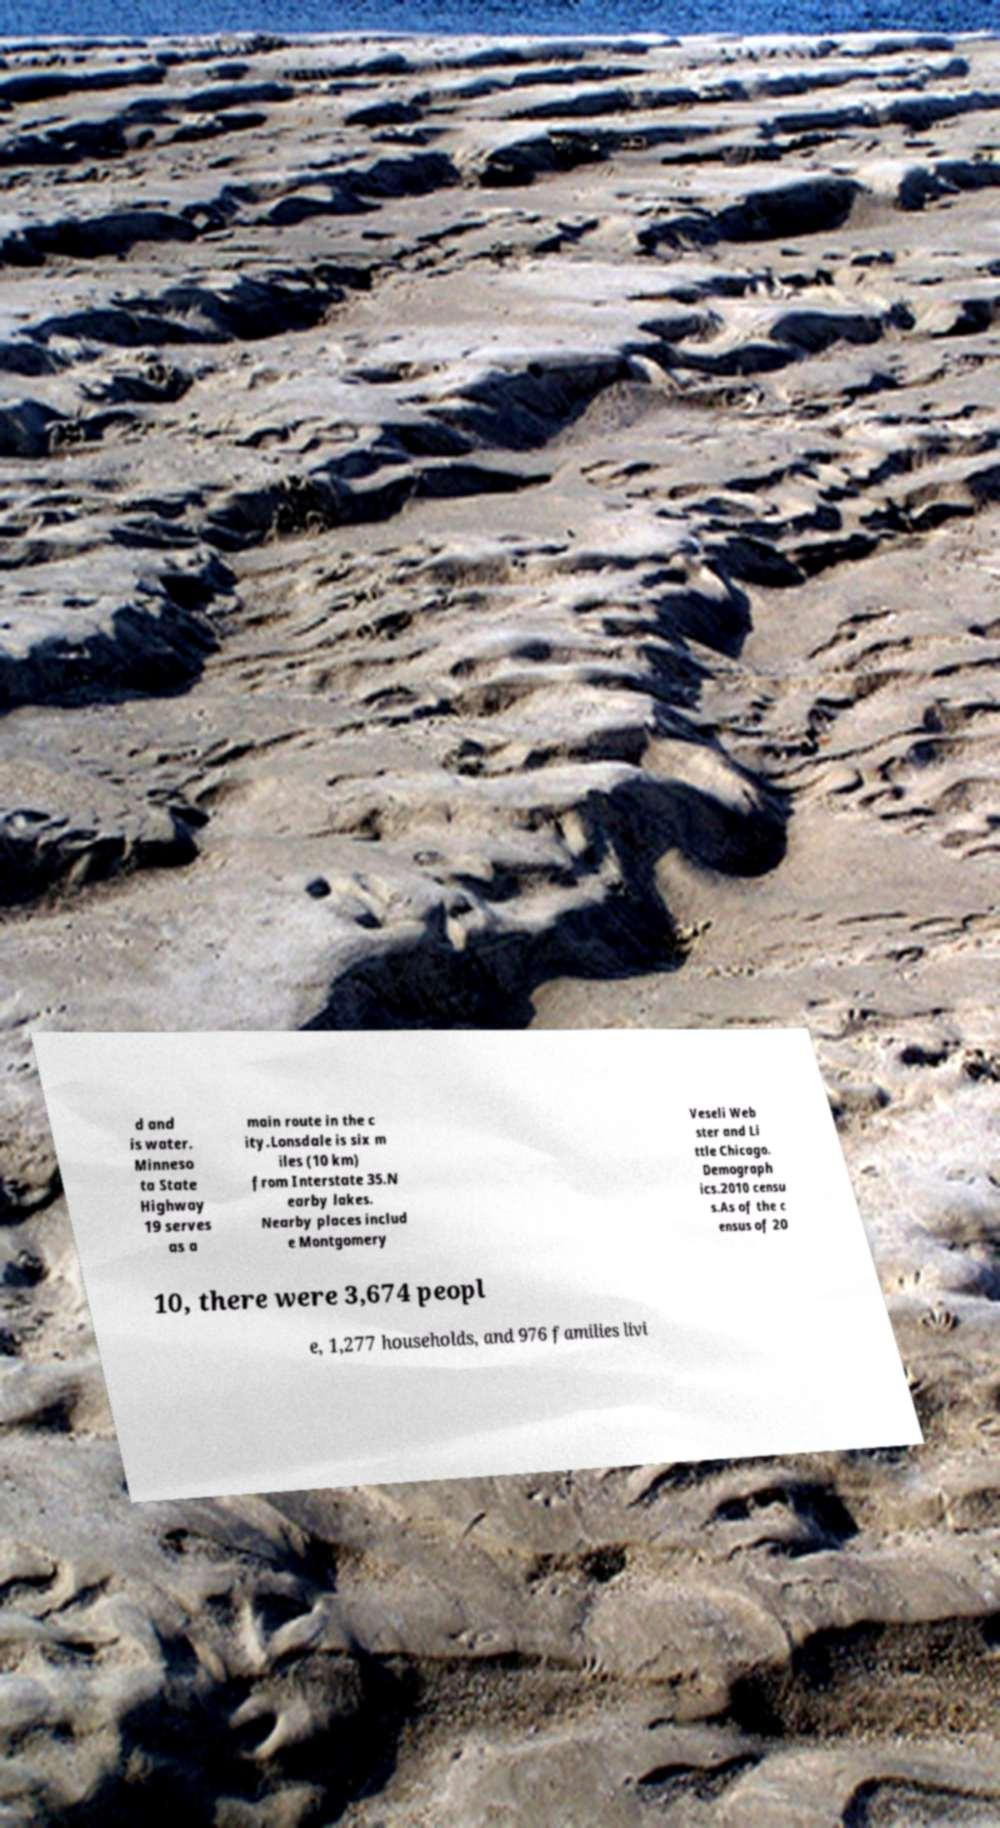Can you accurately transcribe the text from the provided image for me? d and is water. Minneso ta State Highway 19 serves as a main route in the c ity.Lonsdale is six m iles (10 km) from Interstate 35.N earby lakes. Nearby places includ e Montgomery Veseli Web ster and Li ttle Chicago. Demograph ics.2010 censu s.As of the c ensus of 20 10, there were 3,674 peopl e, 1,277 households, and 976 families livi 